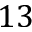Convert formula to latex. <formula><loc_0><loc_0><loc_500><loc_500>1 3</formula> 